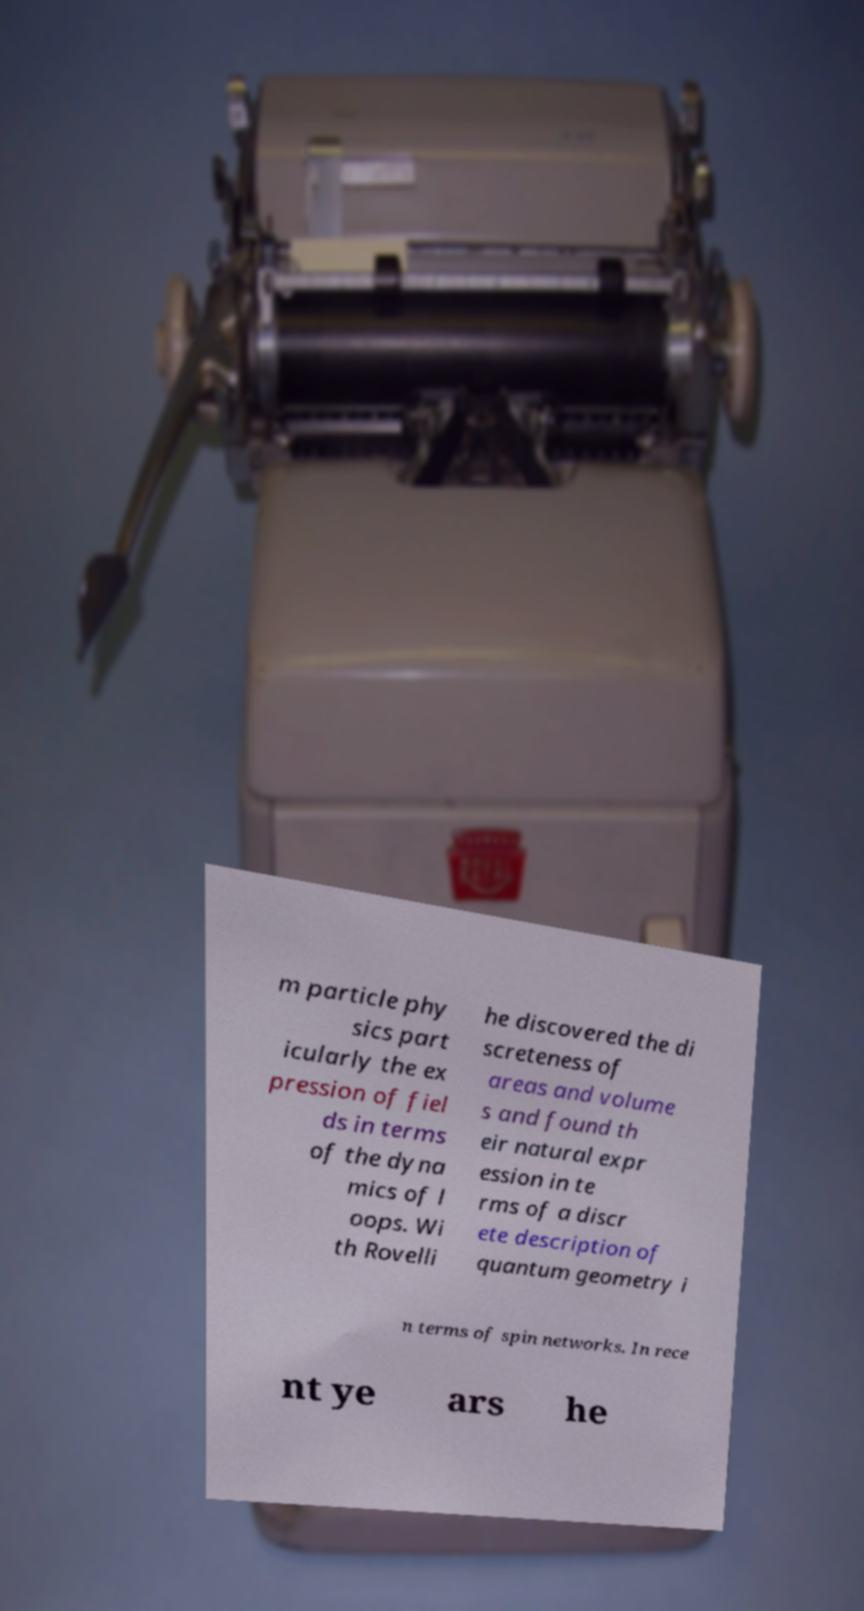Could you assist in decoding the text presented in this image and type it out clearly? m particle phy sics part icularly the ex pression of fiel ds in terms of the dyna mics of l oops. Wi th Rovelli he discovered the di screteness of areas and volume s and found th eir natural expr ession in te rms of a discr ete description of quantum geometry i n terms of spin networks. In rece nt ye ars he 